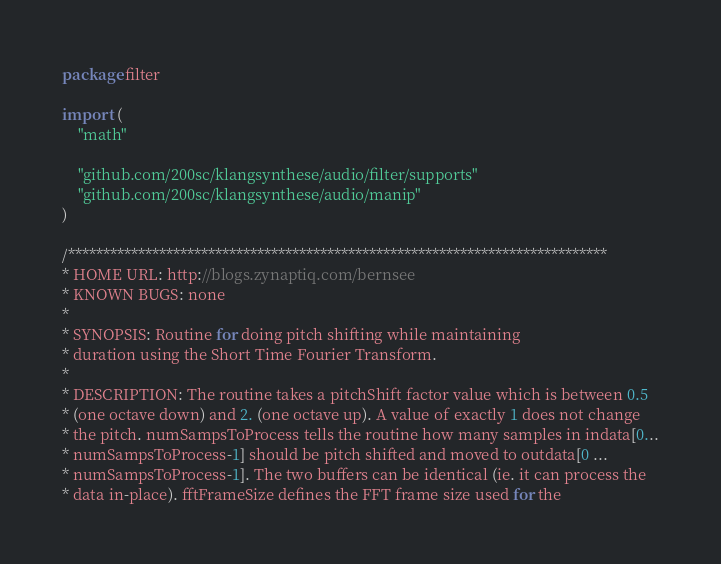<code> <loc_0><loc_0><loc_500><loc_500><_Go_>package filter

import (
	"math"

	"github.com/200sc/klangsynthese/audio/filter/supports"
	"github.com/200sc/klangsynthese/audio/manip"
)

/*****************************************************************************
* HOME URL: http://blogs.zynaptiq.com/bernsee
* KNOWN BUGS: none
*
* SYNOPSIS: Routine for doing pitch shifting while maintaining
* duration using the Short Time Fourier Transform.
*
* DESCRIPTION: The routine takes a pitchShift factor value which is between 0.5
* (one octave down) and 2. (one octave up). A value of exactly 1 does not change
* the pitch. numSampsToProcess tells the routine how many samples in indata[0...
* numSampsToProcess-1] should be pitch shifted and moved to outdata[0 ...
* numSampsToProcess-1]. The two buffers can be identical (ie. it can process the
* data in-place). fftFrameSize defines the FFT frame size used for the</code> 